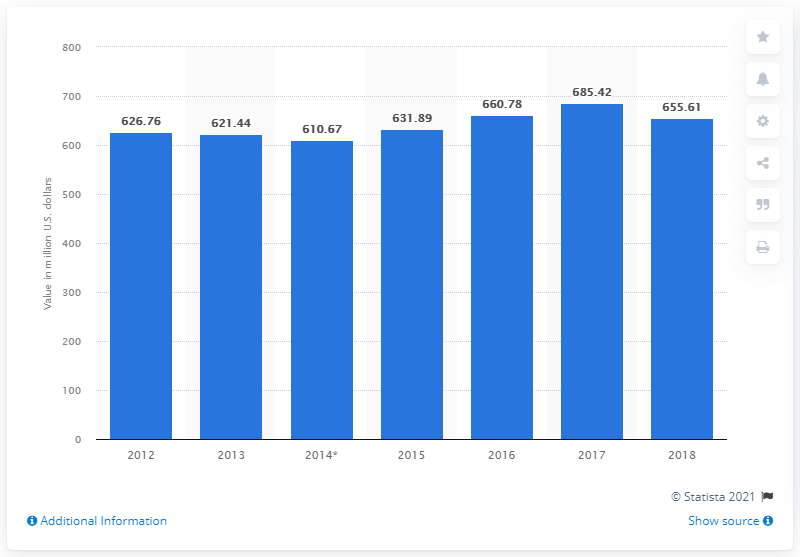Outline some significant characteristics in this image. In 2018, a total of 655.61 metric tons of cocoa valued at X dollars was exported from Mexico. 